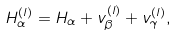<formula> <loc_0><loc_0><loc_500><loc_500>H ^ { ( l ) } _ { \alpha } = H _ { \alpha } + v _ { \beta } ^ { ( l ) } + v _ { \gamma } ^ { ( l ) } ,</formula> 